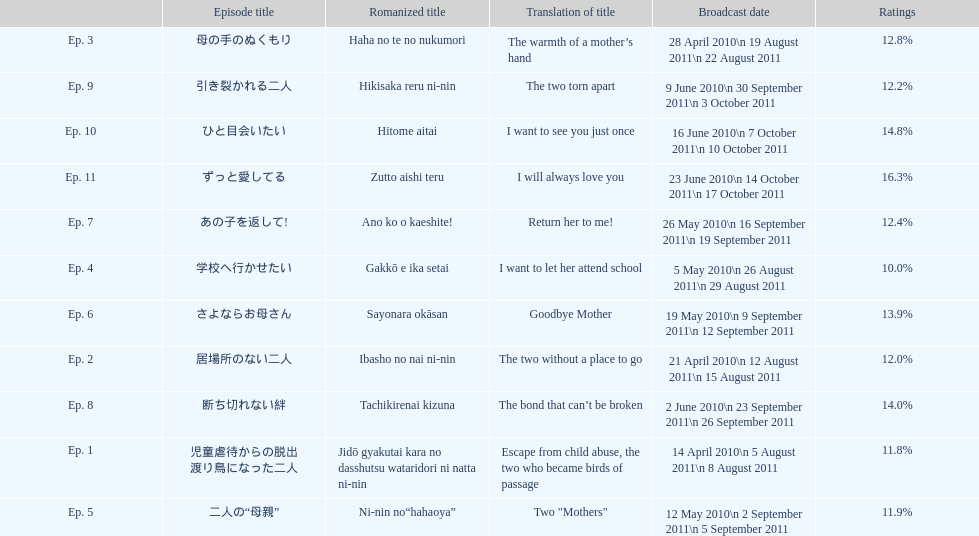What was the top rated episode of this show? ずっと愛してる. 